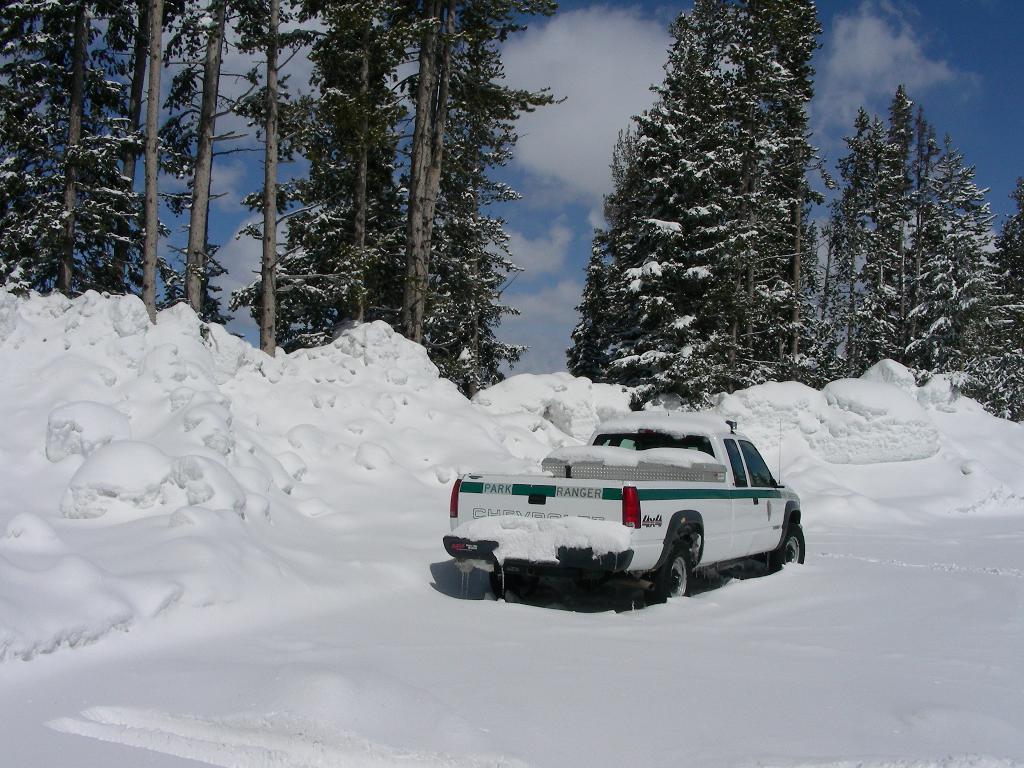Can you describe this image briefly? This image is taken outdoors. At the top of the image there is the sky with clouds. In the background there are a few trees with leaves, stems and branches. Those trees are covered with snow. There is snow. In the middle of the image a vehicle is moving in the snow. 